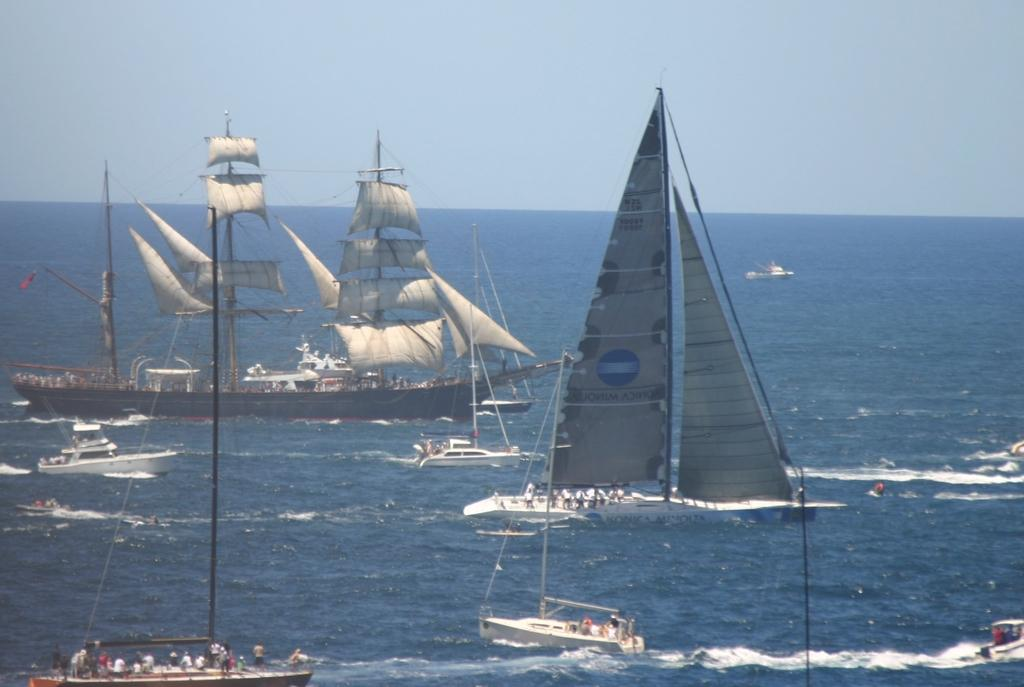What is the main subject of the image? The main subject of the image is ships. Are there any people present in the image? Yes, there are people inside the ships. What can be seen on the poles in the image? There is a white cloth on the poles. What color is the water in the image? The water is blue. What color is the sky in the image? The sky is blue. How many ornaments are hanging from the ships in the image? There are no ornaments hanging from the ships in the image. Can you see any land in the image? The image only shows ships and water, so there is no land visible. 